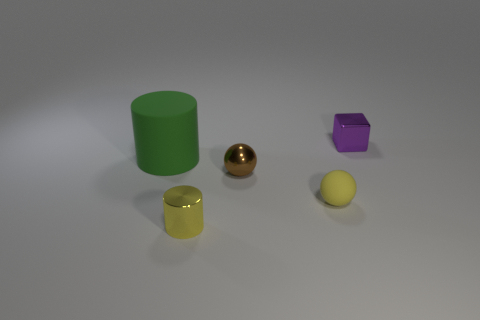Add 2 yellow rubber things. How many objects exist? 7 Subtract all cylinders. How many objects are left? 3 Subtract all purple cylinders. Subtract all yellow metal cylinders. How many objects are left? 4 Add 4 cylinders. How many cylinders are left? 6 Add 2 small red shiny things. How many small red shiny things exist? 2 Subtract 1 yellow balls. How many objects are left? 4 